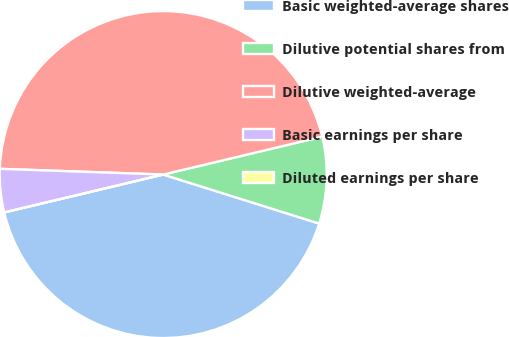Convert chart to OTSL. <chart><loc_0><loc_0><loc_500><loc_500><pie_chart><fcel>Basic weighted-average shares<fcel>Dilutive potential shares from<fcel>Dilutive weighted-average<fcel>Basic earnings per share<fcel>Diluted earnings per share<nl><fcel>41.43%<fcel>8.57%<fcel>45.72%<fcel>4.28%<fcel>0.0%<nl></chart> 